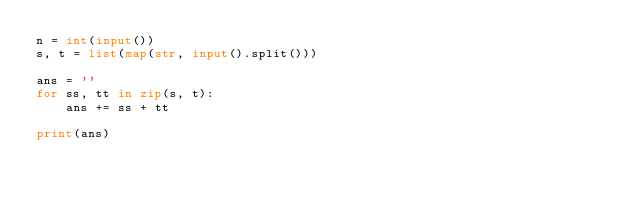Convert code to text. <code><loc_0><loc_0><loc_500><loc_500><_Python_>n = int(input()) 
s, t = list(map(str, input().split()))

ans = ''
for ss, tt in zip(s, t):
    ans += ss + tt
    
print(ans)</code> 